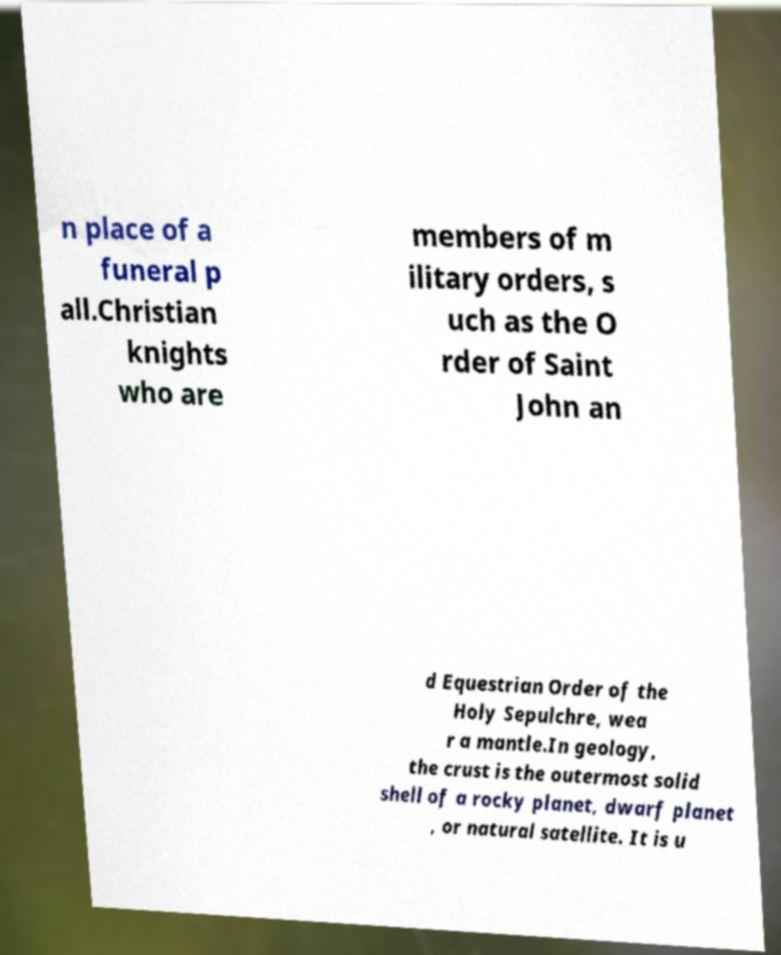What messages or text are displayed in this image? I need them in a readable, typed format. n place of a funeral p all.Christian knights who are members of m ilitary orders, s uch as the O rder of Saint John an d Equestrian Order of the Holy Sepulchre, wea r a mantle.In geology, the crust is the outermost solid shell of a rocky planet, dwarf planet , or natural satellite. It is u 